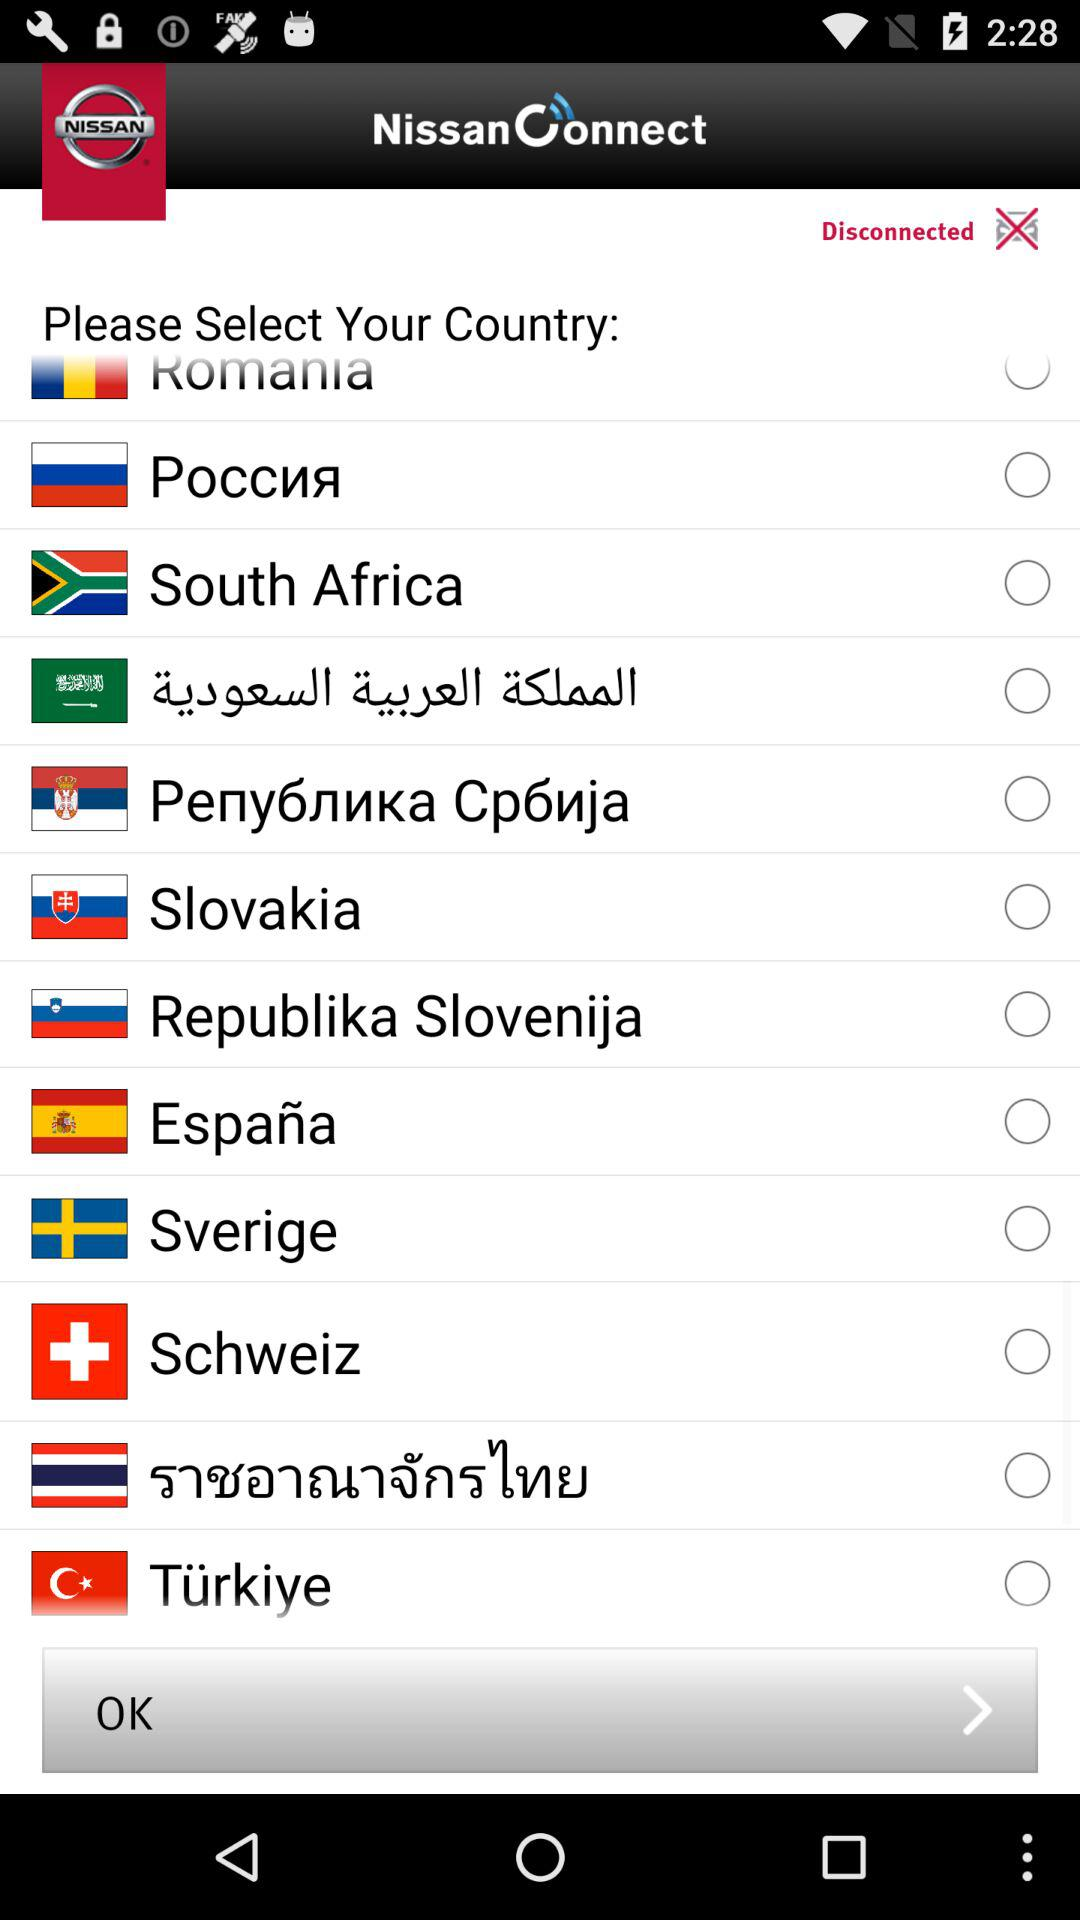What is the app name? The app name is "NissanEvent". 